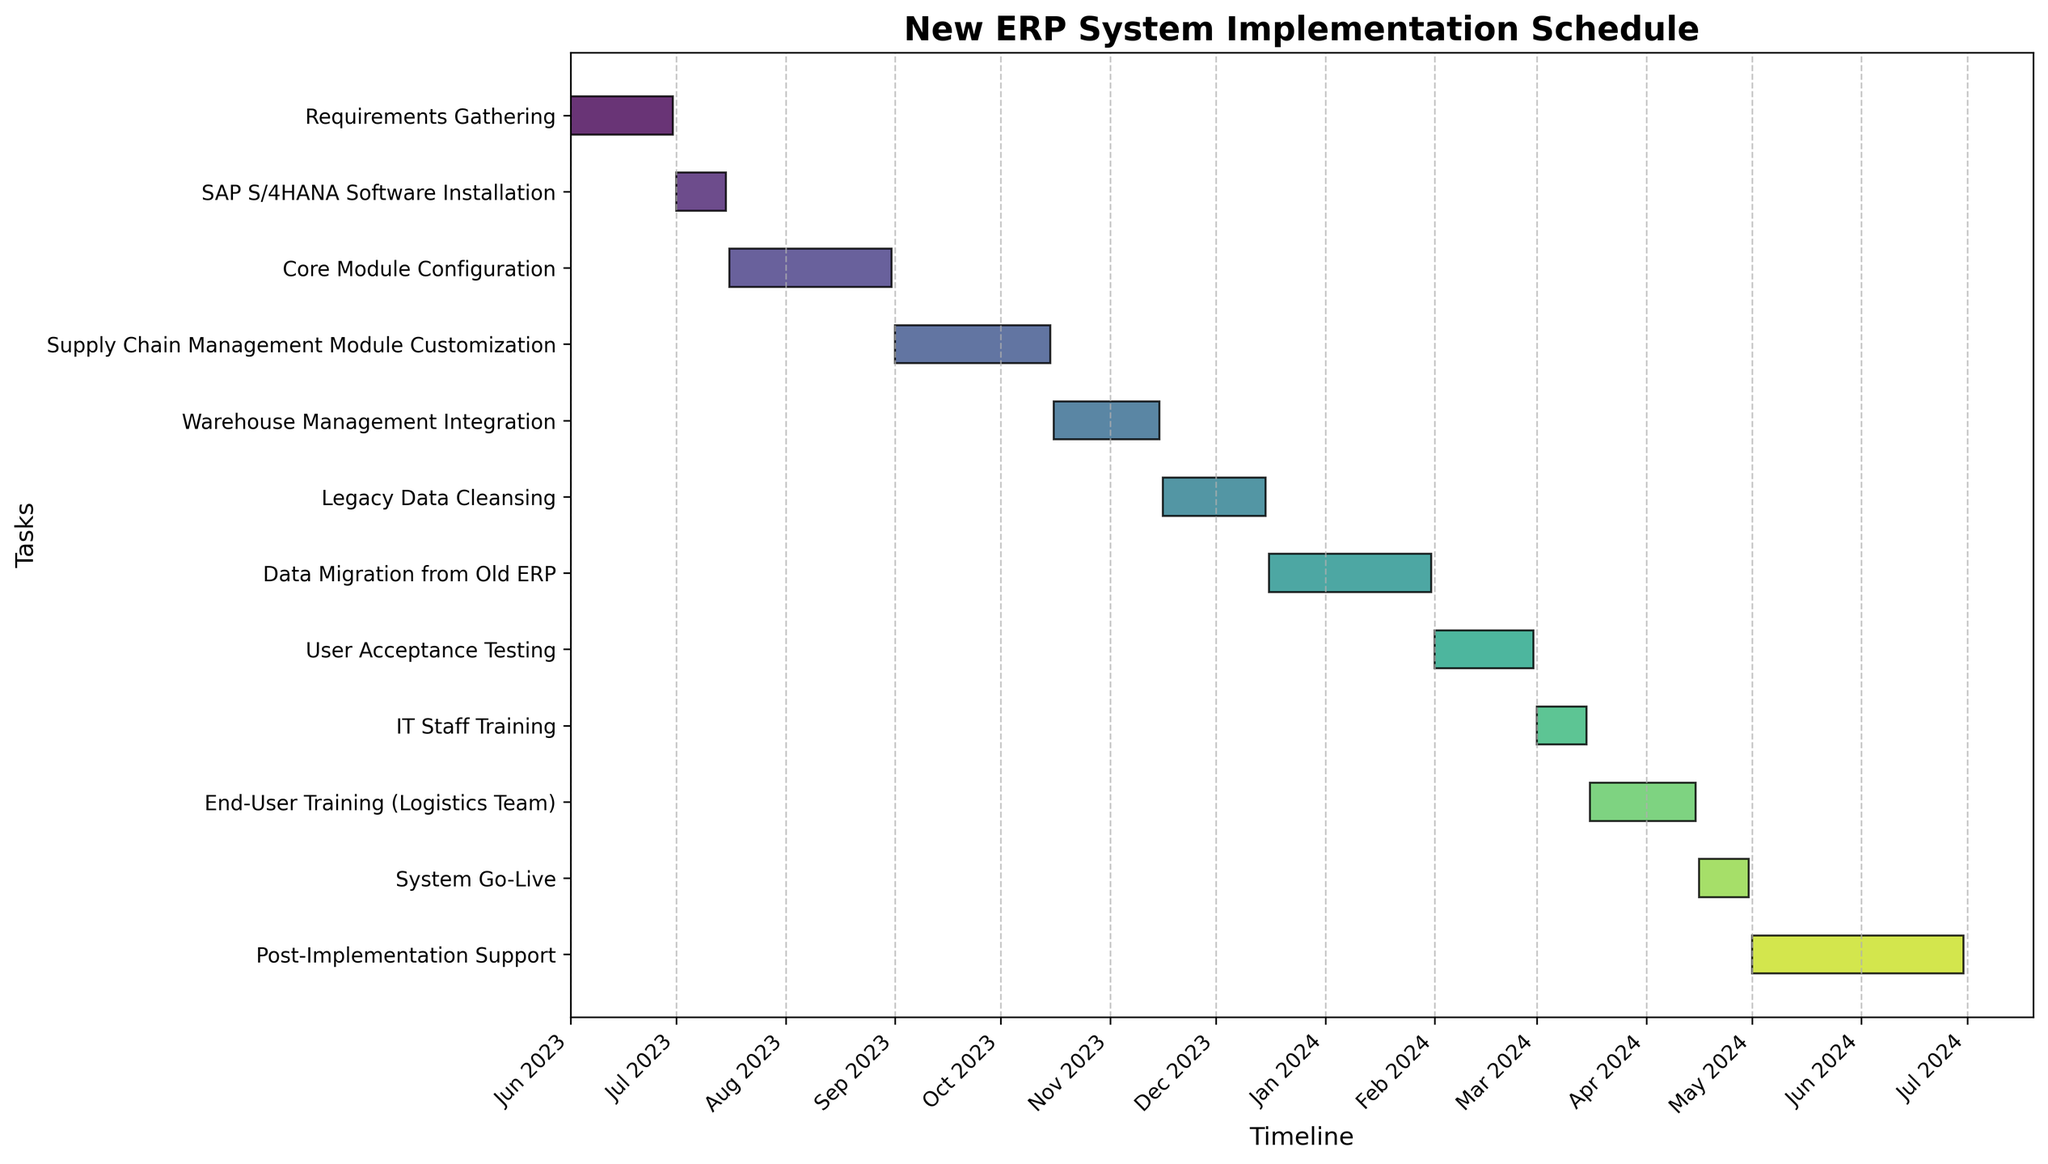What is the title of the chart? The title is located at the top of the chart, usually in a larger and bolder font. It typically describes what the chart represents.
Answer: New ERP System Implementation Schedule How many tasks are scheduled in the implementation plan? Count the number of horizontal bars or tasks listed on the y-axis. Each bar represents one task.
Answer: 12 Which task has the shortest duration? Identify the bar with the smallest length on the horizontal axis.
Answer: SAP S/4HANA Software Installation When does the Data Migration from Old ERP start and end? Locate the bar labeled "Data Migration from Old ERP" on the y-axis and check its starting and ending points on the x-axis.
Answer: It starts on 2023-12-16 and ends on 2024-01-31 What is the total duration of the supply chain management module customization? Locate the Supply Chain Management Module Customization bar and measure its length from start to end date.
Answer: 45 days Which two tasks overlap in November 2023? Identify the bars that span over November 2023 and check which ones overlap.
Answer: Warehouse Management Integration and Legacy Data Cleansing How much time is allocated for the user training phases combined? Sum the durations of IT Staff Training and End-User Training (Logistics Team). These can be determined by the lengths of the corresponding bars on the y-axis.
Answer: 45 days Which phase immediately follows the Core Module Configuration? Find the end date of Core Module Configuration and locate the next task that starts right after.
Answer: Supply Chain Management Module Customization How does the duration of User Acceptance Testing compare to Post-Implementation Support? Measure the lengths of the User Acceptance Testing and Post-Implementation Support bars and compare them.
Answer: User Acceptance Testing is shorter than Post-Implementation Support What is the final activity in the Gantt chart, and when does it end? Look for the last bar in the order of appearance on the y-axis and note its end date.
Answer: Post-Implementation Support, ends on 2024-06-30 